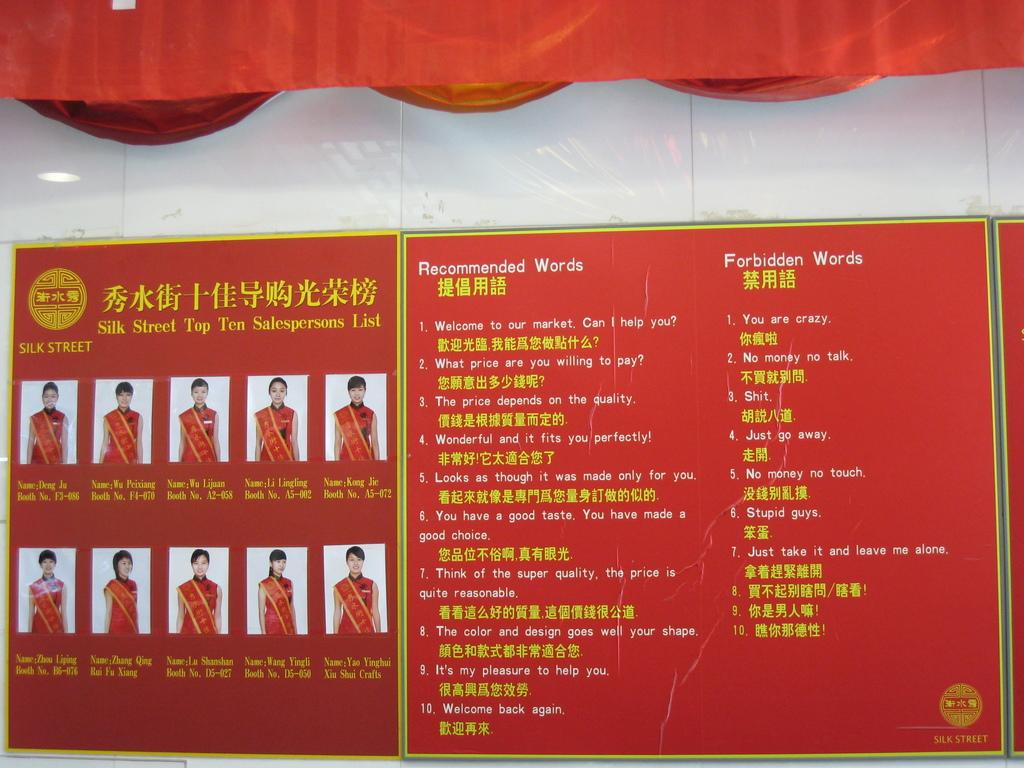<image>
Present a compact description of the photo's key features. Pictures of Top Ten Salespersons and text next to them. 